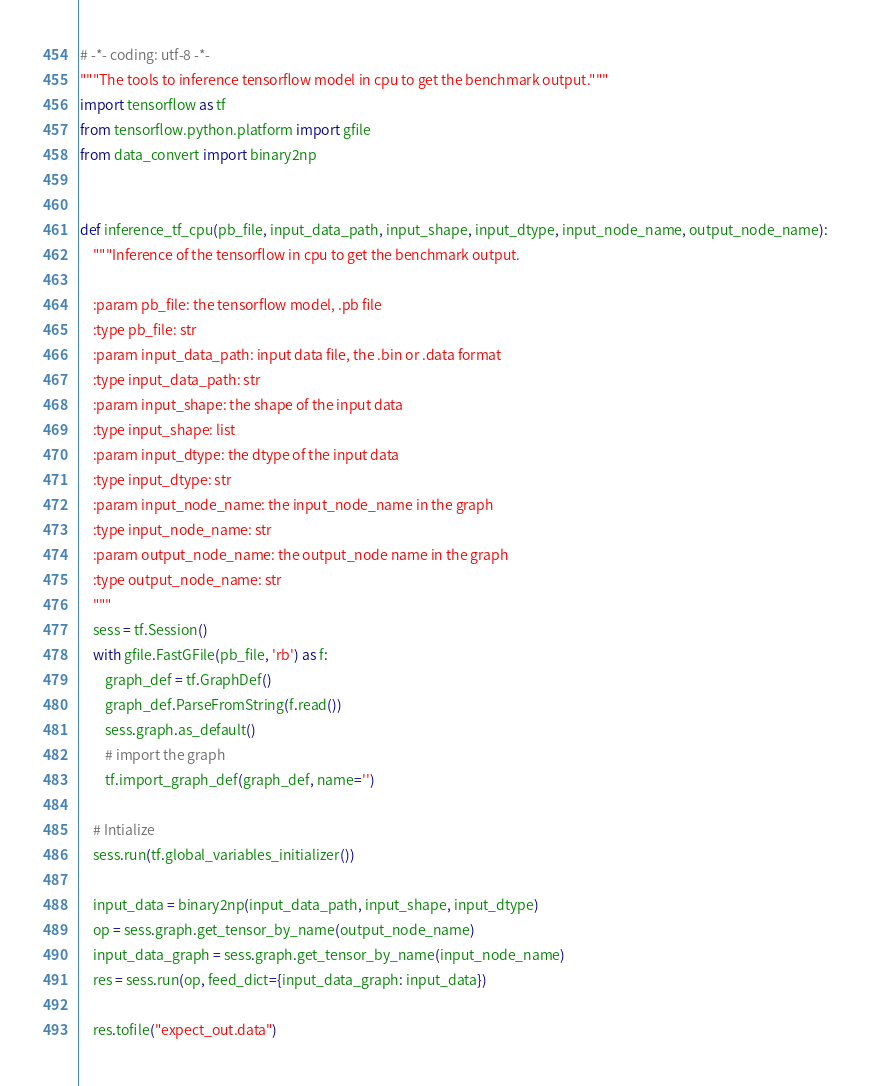<code> <loc_0><loc_0><loc_500><loc_500><_Python_># -*- coding: utf-8 -*-
"""The tools to inference tensorflow model in cpu to get the benchmark output."""
import tensorflow as tf
from tensorflow.python.platform import gfile
from data_convert import binary2np


def inference_tf_cpu(pb_file, input_data_path, input_shape, input_dtype, input_node_name, output_node_name):
    """Inference of the tensorflow in cpu to get the benchmark output.

    :param pb_file: the tensorflow model, .pb file
    :type pb_file: str
    :param input_data_path: input data file, the .bin or .data format
    :type input_data_path: str
    :param input_shape: the shape of the input data
    :type input_shape: list
    :param input_dtype: the dtype of the input data
    :type input_dtype: str
    :param input_node_name: the input_node_name in the graph
    :type input_node_name: str
    :param output_node_name: the output_node name in the graph
    :type output_node_name: str
    """
    sess = tf.Session()
    with gfile.FastGFile(pb_file, 'rb') as f:
        graph_def = tf.GraphDef()
        graph_def.ParseFromString(f.read())
        sess.graph.as_default()
        # import the graph
        tf.import_graph_def(graph_def, name='')

    # Intialize
    sess.run(tf.global_variables_initializer())

    input_data = binary2np(input_data_path, input_shape, input_dtype)
    op = sess.graph.get_tensor_by_name(output_node_name)
    input_data_graph = sess.graph.get_tensor_by_name(input_node_name)
    res = sess.run(op, feed_dict={input_data_graph: input_data})

    res.tofile("expect_out.data")
</code> 